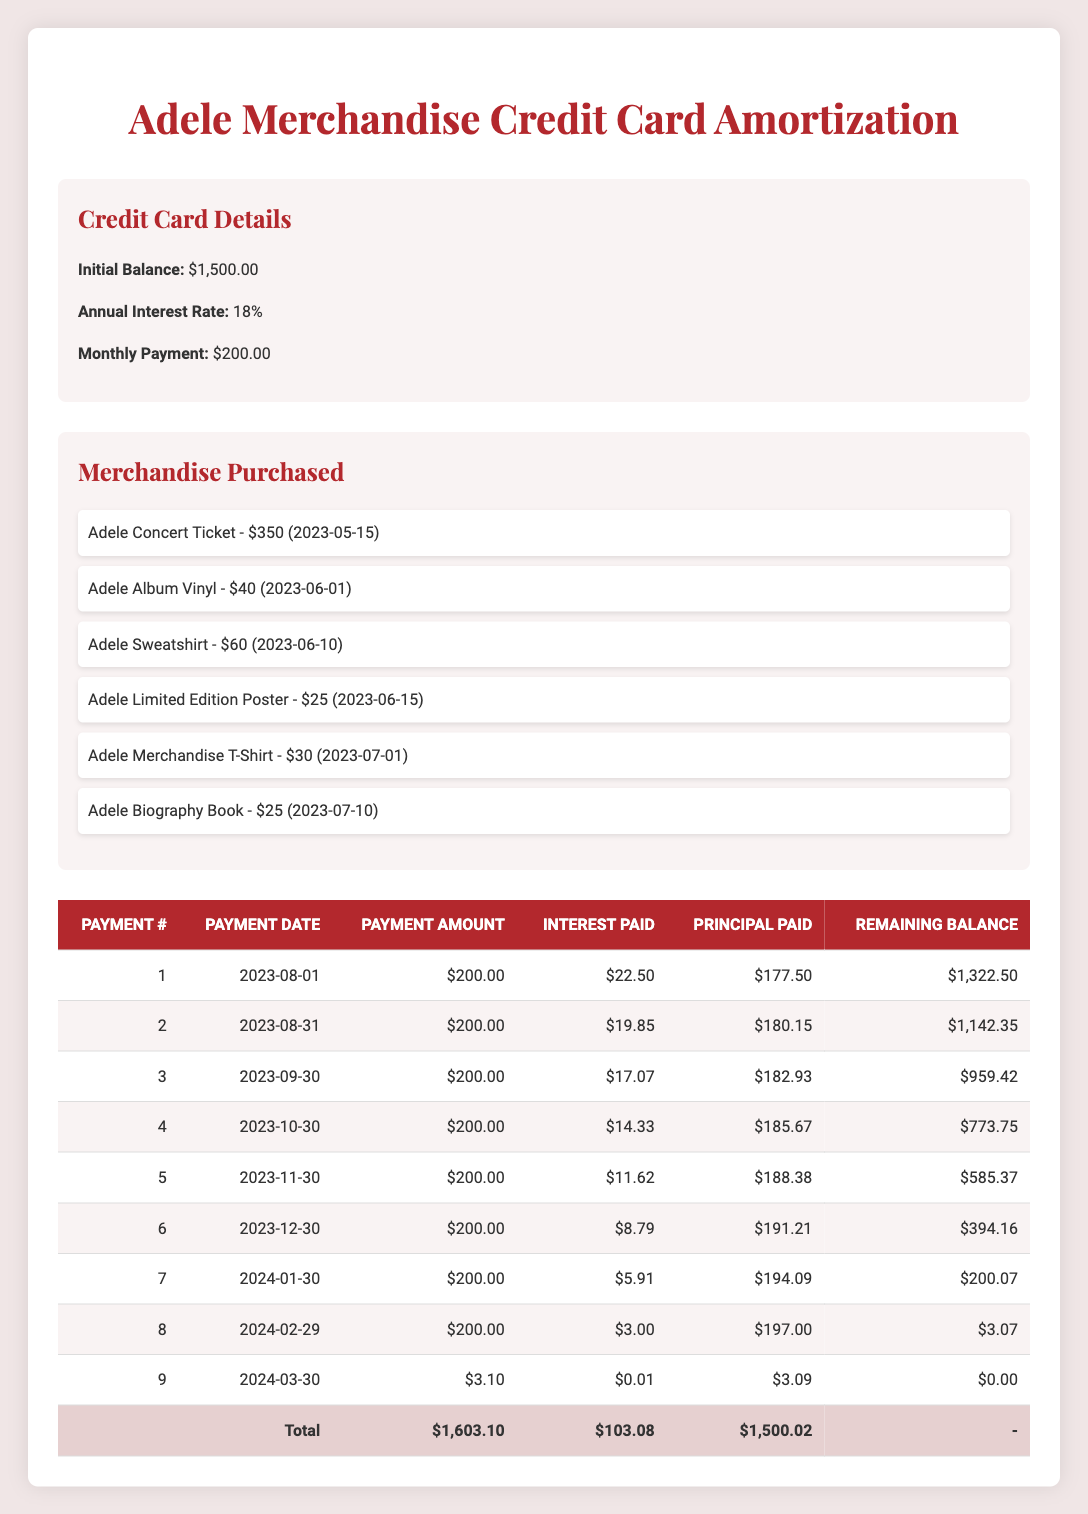What is the total amount paid across all payments? To find the total amount paid, sum the "Payment Amount" column. The values are 200, 200, 200, 200, 200, 200, 200, 200, and 3.10. Adding these amounts together gives 1,603.10.
Answer: 1,603.10 What was the interest paid in the last payment? Referring to the last row of the table, the "Interest Paid" for the ninth payment is recorded as 0.01.
Answer: 0.01 How much principal was paid in the 5th payment? Looking at the payment details in the fifth row, the "Principal Paid" amount is noted as 188.38.
Answer: 188.38 What is the remaining balance after the 6th payment? The "Remaining Balance" after the 6th payment can be found in the sixth row of the table, which shows a remaining balance of 394.16.
Answer: 394.16 Did the total interest paid exceed $100? By examining the total interest paid, it can be found in the last row, where it is $103.08, which is more than $100.
Answer: Yes How much did the "Adele Concert Ticket" contribute to the initial balance? The "Adele Concert Ticket" costs $350, contributing this entire amount to the initial balance of $1,500.
Answer: 350 What is the average interest paid per payment? To calculate the average interest paid, add the interest amounts from all payments (22.50 + 19.85 + 17.07 + 14.33 + 11.62 + 8.79 + 5.91 + 3.00 + 0.01 = 103.08) and divide by the number of payments (9). This results in an average interest of about 11.45.
Answer: 11.45 How much total principal was paid by the 4th payment? By summing the "Principal Paid" amounts from the first four payments (177.50 + 180.15 + 182.93 + 185.67 = 726.25), we can determine that a total principal of 726.25 was paid by the 4th payment.
Answer: 726.25 What is the remaining balance after the first payment? Checking the table, after the first payment, the remaining balance is 1,322.50, as noted in the first payment details.
Answer: 1,322.50 